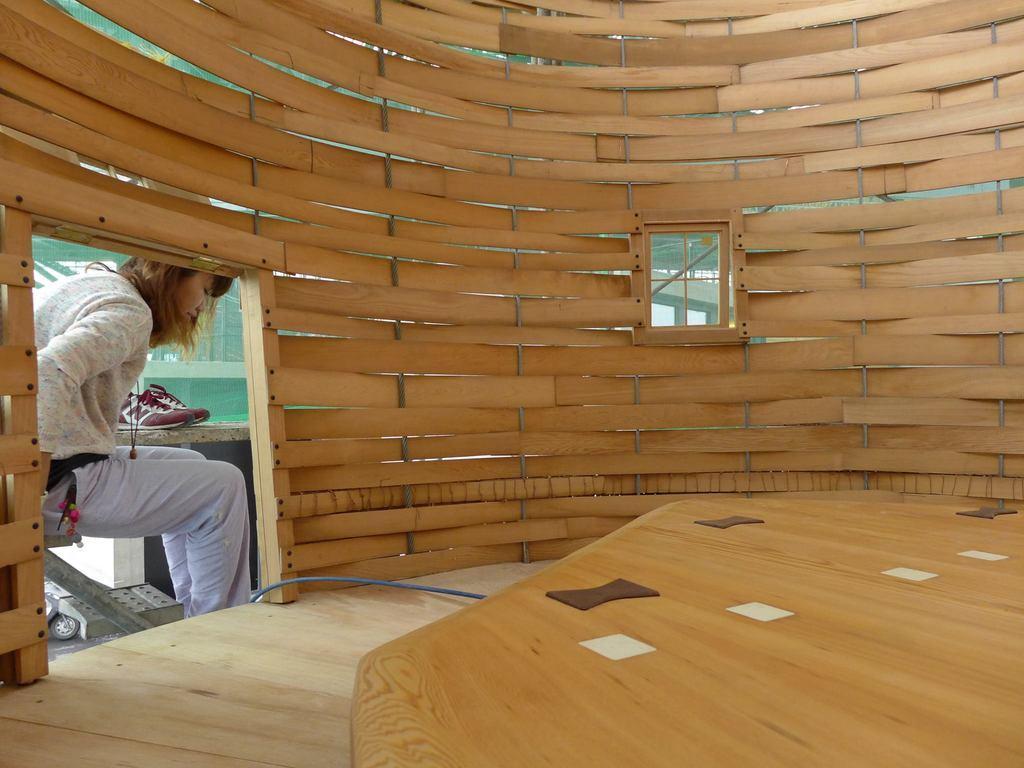Can you describe this image briefly? In this image it looks like it is a wooden house which is in circular shape. In the middle there is a wooden table. On the left side there is a girl who is sitting on the trolley. Beside her there are shoes on the desk. 